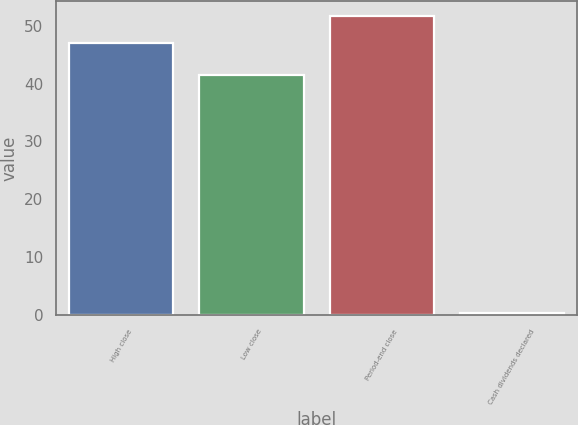<chart> <loc_0><loc_0><loc_500><loc_500><bar_chart><fcel>High close<fcel>Low close<fcel>Period-end close<fcel>Cash dividends declared<nl><fcel>47.01<fcel>41.43<fcel>51.68<fcel>0.34<nl></chart> 